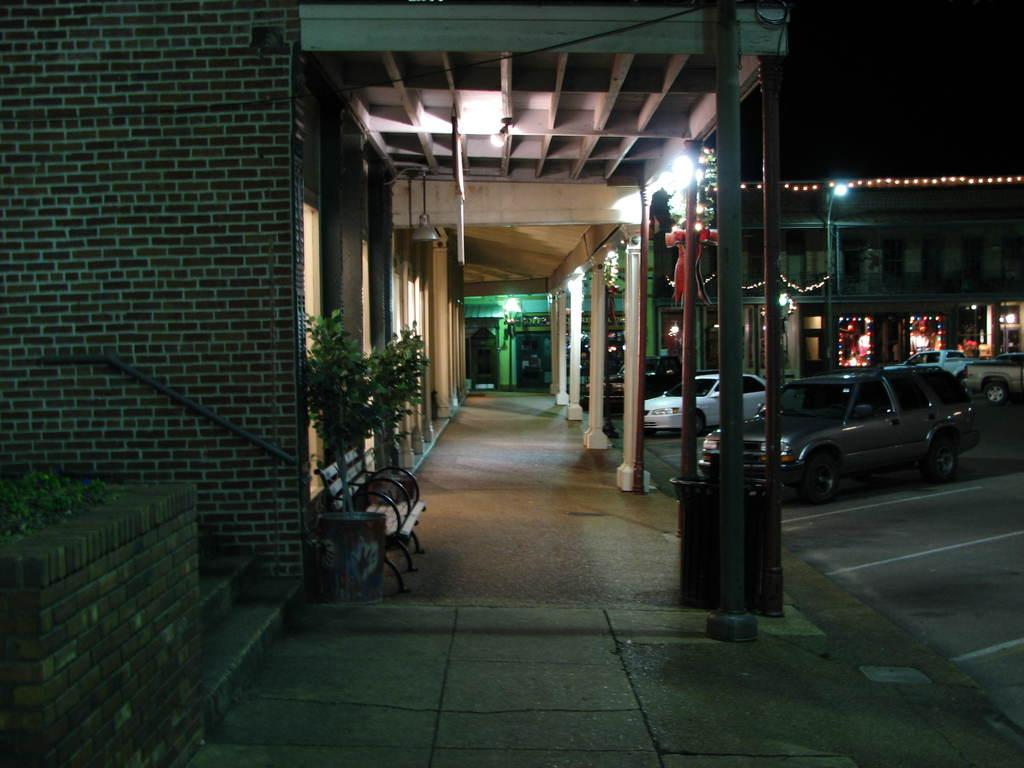How are the buildings in the image decorated? The buildings in the image are decorated with electric lights. What is located in front of the building? There is a bench and a tree in front of the building. What can be seen on the road in the image? Vehicles are parked on the road. What is the color of the background in the image? The background of the image is dark. Can you hear the tree crying in the image? Trees do not have the ability to cry, and there is no sound in the image. What type of rake is being used to maintain the grass in the image? There is no rake present in the image, and the grass is not being maintained in the image. 